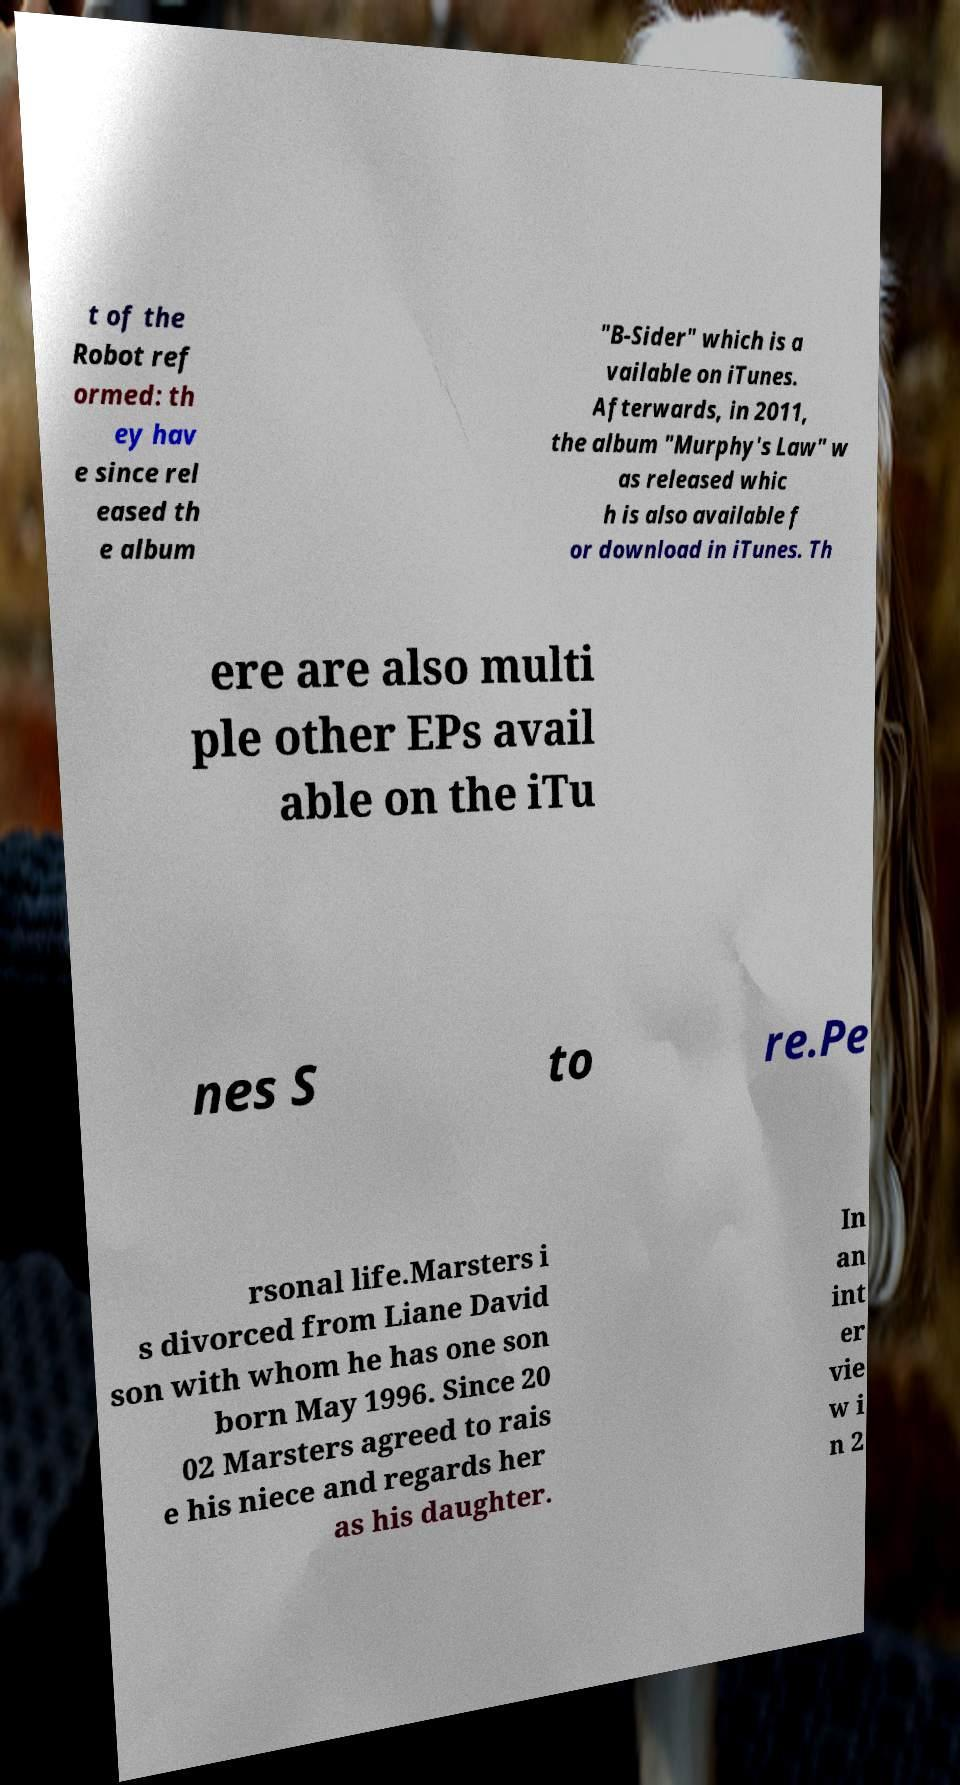There's text embedded in this image that I need extracted. Can you transcribe it verbatim? t of the Robot ref ormed: th ey hav e since rel eased th e album "B-Sider" which is a vailable on iTunes. Afterwards, in 2011, the album "Murphy's Law" w as released whic h is also available f or download in iTunes. Th ere are also multi ple other EPs avail able on the iTu nes S to re.Pe rsonal life.Marsters i s divorced from Liane David son with whom he has one son born May 1996. Since 20 02 Marsters agreed to rais e his niece and regards her as his daughter. In an int er vie w i n 2 